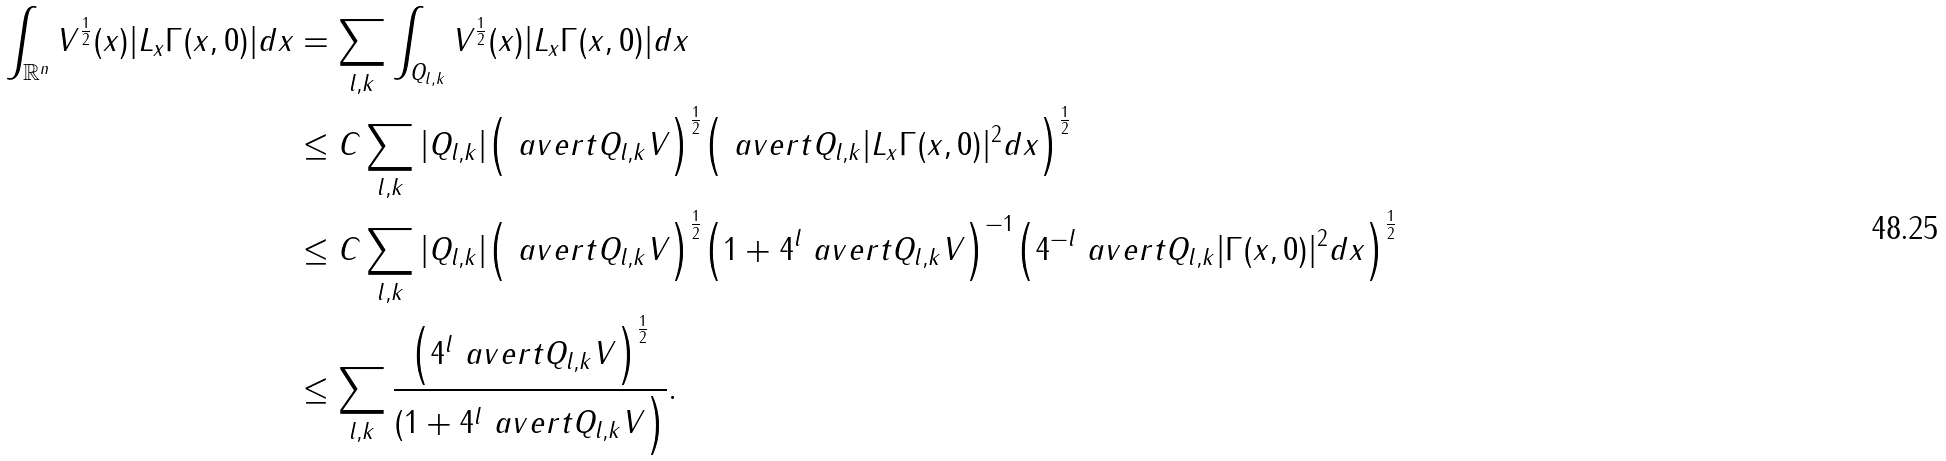Convert formula to latex. <formula><loc_0><loc_0><loc_500><loc_500>\int _ { \mathbb { R } ^ { n } } V ^ { \frac { 1 } { 2 } } ( x ) | L _ { x } \Gamma ( x , 0 ) | d x & = \sum _ { l , k } \int _ { Q _ { l , k } } V ^ { \frac { 1 } { 2 } } ( x ) | L _ { x } \Gamma ( x , 0 ) | d x \\ & \leq C \sum _ { l , k } | Q _ { l , k } | \Big ( \ a v e r t { Q _ { l , k } } V \Big ) ^ { \frac { 1 } { 2 } } \Big ( \ a v e r t { Q _ { l , k } } | L _ { x } \Gamma ( x , 0 ) | ^ { 2 } d x \Big ) ^ { \frac { 1 } { 2 } } \\ & \leq C \sum _ { l , k } | Q _ { l , k } | \Big ( \ a v e r t { Q _ { l , k } } V \Big ) ^ { \frac { 1 } { 2 } } \Big ( 1 + 4 ^ { l } \ a v e r t { Q _ { l , k } } V \Big ) ^ { - 1 } \Big ( 4 ^ { - l } \ a v e r t { Q _ { l , k } } | \Gamma ( x , 0 ) | ^ { 2 } d x \Big ) ^ { \frac { 1 } { 2 } } \\ & \leq \sum _ { l , k } \frac { \Big ( 4 ^ { l } \ a v e r t { Q _ { l , k } } V \Big ) ^ { \frac { 1 } { 2 } } } { ( 1 + 4 ^ { l } \ a v e r t { Q _ { l , k } } V \Big ) } .</formula> 